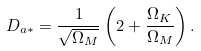Convert formula to latex. <formula><loc_0><loc_0><loc_500><loc_500>D _ { a * } = \frac { 1 } { \sqrt { \Omega _ { M } } } \left ( 2 + \frac { \Omega _ { K } } { \Omega _ { M } } \right ) .</formula> 